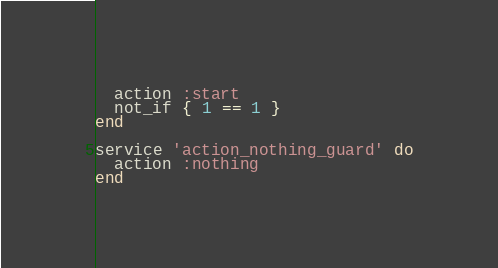Convert code to text. <code><loc_0><loc_0><loc_500><loc_500><_Ruby_>  action :start
  not_if { 1 == 1 }
end

service 'action_nothing_guard' do
  action :nothing
end
</code> 